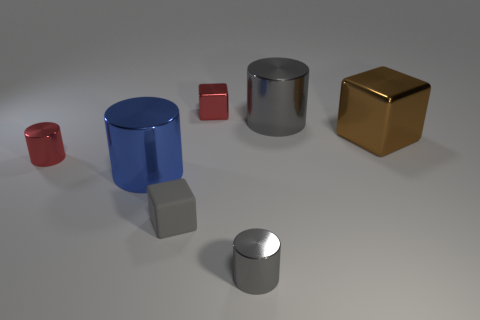Is there any other thing that is made of the same material as the small gray block?
Your answer should be very brief. No. There is a gray metal cylinder in front of the small red shiny thing in front of the brown thing; what number of brown metal cubes are behind it?
Make the answer very short. 1. How many large objects are either cyan metallic things or rubber blocks?
Offer a very short reply. 0. Is the tiny red object that is behind the brown shiny thing made of the same material as the big gray thing?
Provide a short and direct response. Yes. What material is the small block that is to the left of the small red object to the right of the small red thing left of the tiny matte block made of?
Your response must be concise. Rubber. Is there any other thing that has the same size as the red shiny cylinder?
Provide a short and direct response. Yes. What number of rubber objects are large brown spheres or blue cylinders?
Provide a short and direct response. 0. Are there any small blue rubber cylinders?
Keep it short and to the point. No. There is a tiny metallic cylinder that is left of the tiny metallic cylinder in front of the gray matte object; what color is it?
Your answer should be compact. Red. What number of other things are the same color as the big metallic block?
Ensure brevity in your answer.  0. 